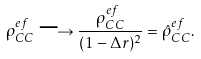<formula> <loc_0><loc_0><loc_500><loc_500>\rho _ { C C } ^ { e f } \longrightarrow \frac { \rho _ { C C } ^ { e f } } { ( 1 - \Delta r ) ^ { 2 } } = \hat { \rho } _ { C C } ^ { e f } .</formula> 